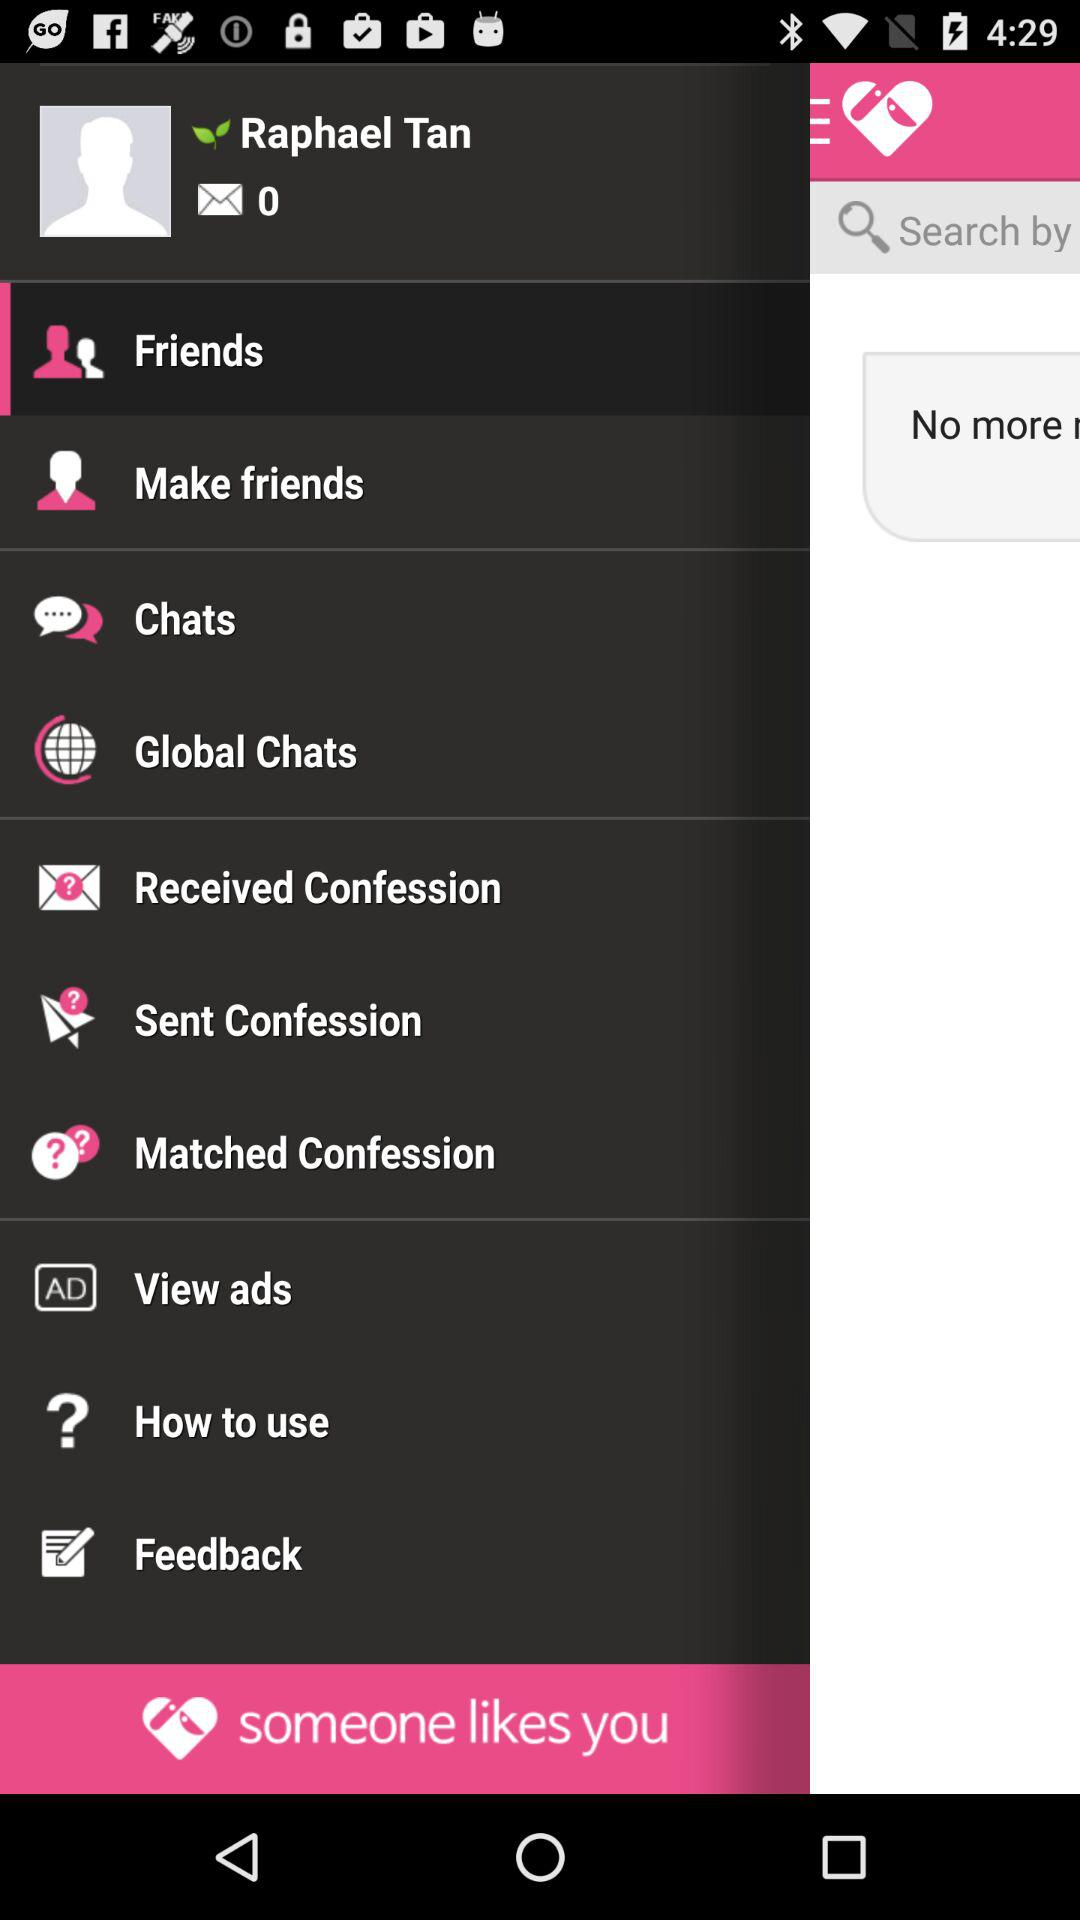What is the name? The name is Raphael Tan. 